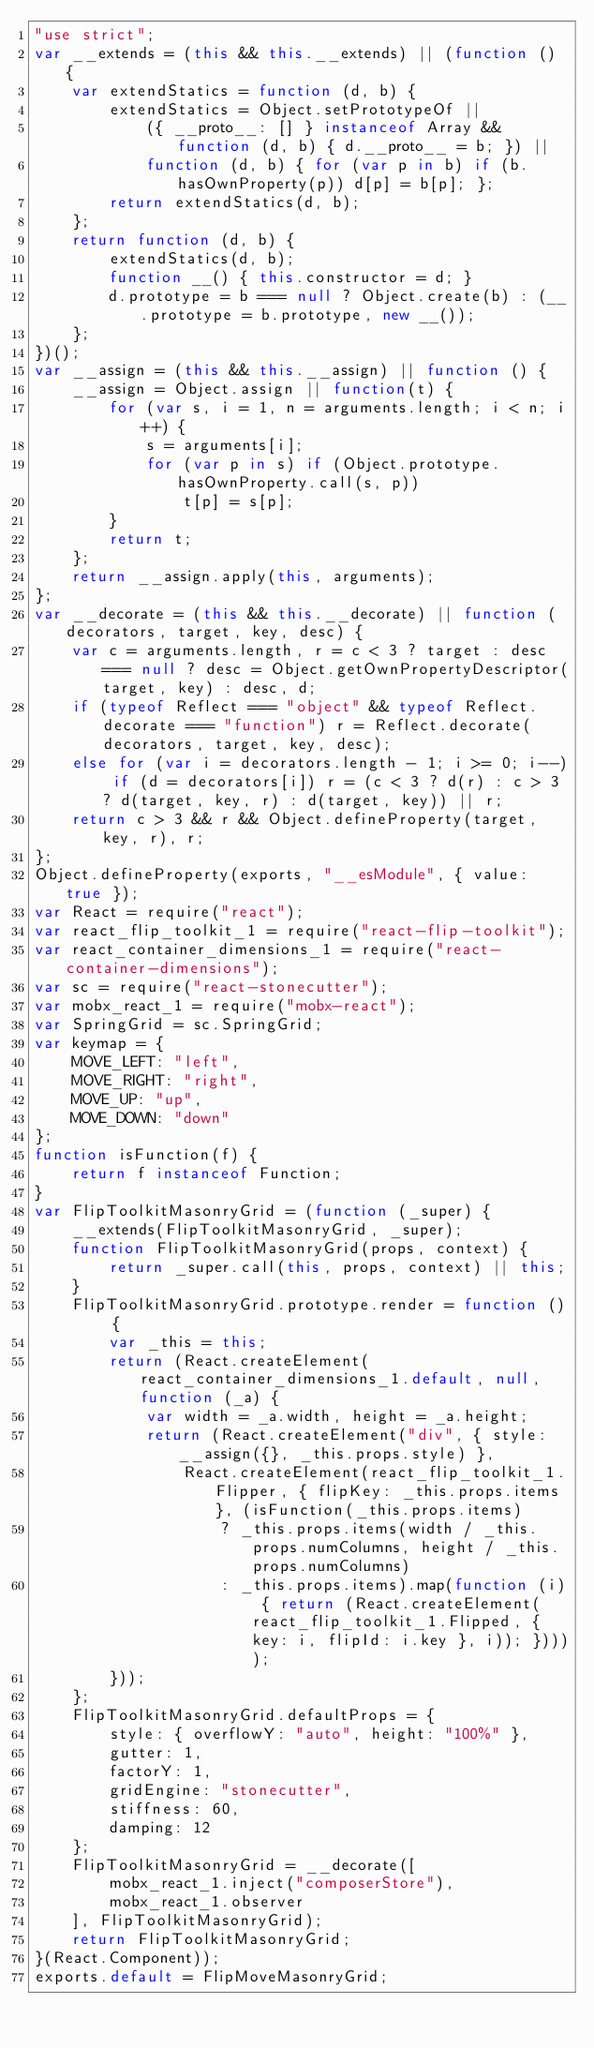Convert code to text. <code><loc_0><loc_0><loc_500><loc_500><_JavaScript_>"use strict";
var __extends = (this && this.__extends) || (function () {
    var extendStatics = function (d, b) {
        extendStatics = Object.setPrototypeOf ||
            ({ __proto__: [] } instanceof Array && function (d, b) { d.__proto__ = b; }) ||
            function (d, b) { for (var p in b) if (b.hasOwnProperty(p)) d[p] = b[p]; };
        return extendStatics(d, b);
    };
    return function (d, b) {
        extendStatics(d, b);
        function __() { this.constructor = d; }
        d.prototype = b === null ? Object.create(b) : (__.prototype = b.prototype, new __());
    };
})();
var __assign = (this && this.__assign) || function () {
    __assign = Object.assign || function(t) {
        for (var s, i = 1, n = arguments.length; i < n; i++) {
            s = arguments[i];
            for (var p in s) if (Object.prototype.hasOwnProperty.call(s, p))
                t[p] = s[p];
        }
        return t;
    };
    return __assign.apply(this, arguments);
};
var __decorate = (this && this.__decorate) || function (decorators, target, key, desc) {
    var c = arguments.length, r = c < 3 ? target : desc === null ? desc = Object.getOwnPropertyDescriptor(target, key) : desc, d;
    if (typeof Reflect === "object" && typeof Reflect.decorate === "function") r = Reflect.decorate(decorators, target, key, desc);
    else for (var i = decorators.length - 1; i >= 0; i--) if (d = decorators[i]) r = (c < 3 ? d(r) : c > 3 ? d(target, key, r) : d(target, key)) || r;
    return c > 3 && r && Object.defineProperty(target, key, r), r;
};
Object.defineProperty(exports, "__esModule", { value: true });
var React = require("react");
var react_flip_toolkit_1 = require("react-flip-toolkit");
var react_container_dimensions_1 = require("react-container-dimensions");
var sc = require("react-stonecutter");
var mobx_react_1 = require("mobx-react");
var SpringGrid = sc.SpringGrid;
var keymap = {
    MOVE_LEFT: "left",
    MOVE_RIGHT: "right",
    MOVE_UP: "up",
    MOVE_DOWN: "down"
};
function isFunction(f) {
    return f instanceof Function;
}
var FlipToolkitMasonryGrid = (function (_super) {
    __extends(FlipToolkitMasonryGrid, _super);
    function FlipToolkitMasonryGrid(props, context) {
        return _super.call(this, props, context) || this;
    }
    FlipToolkitMasonryGrid.prototype.render = function () {
        var _this = this;
        return (React.createElement(react_container_dimensions_1.default, null, function (_a) {
            var width = _a.width, height = _a.height;
            return (React.createElement("div", { style: __assign({}, _this.props.style) },
                React.createElement(react_flip_toolkit_1.Flipper, { flipKey: _this.props.items }, (isFunction(_this.props.items)
                    ? _this.props.items(width / _this.props.numColumns, height / _this.props.numColumns)
                    : _this.props.items).map(function (i) { return (React.createElement(react_flip_toolkit_1.Flipped, { key: i, flipId: i.key }, i)); }))));
        }));
    };
    FlipToolkitMasonryGrid.defaultProps = {
        style: { overflowY: "auto", height: "100%" },
        gutter: 1,
        factorY: 1,
        gridEngine: "stonecutter",
        stiffness: 60,
        damping: 12
    };
    FlipToolkitMasonryGrid = __decorate([
        mobx_react_1.inject("composerStore"),
        mobx_react_1.observer
    ], FlipToolkitMasonryGrid);
    return FlipToolkitMasonryGrid;
}(React.Component));
exports.default = FlipMoveMasonryGrid;
</code> 